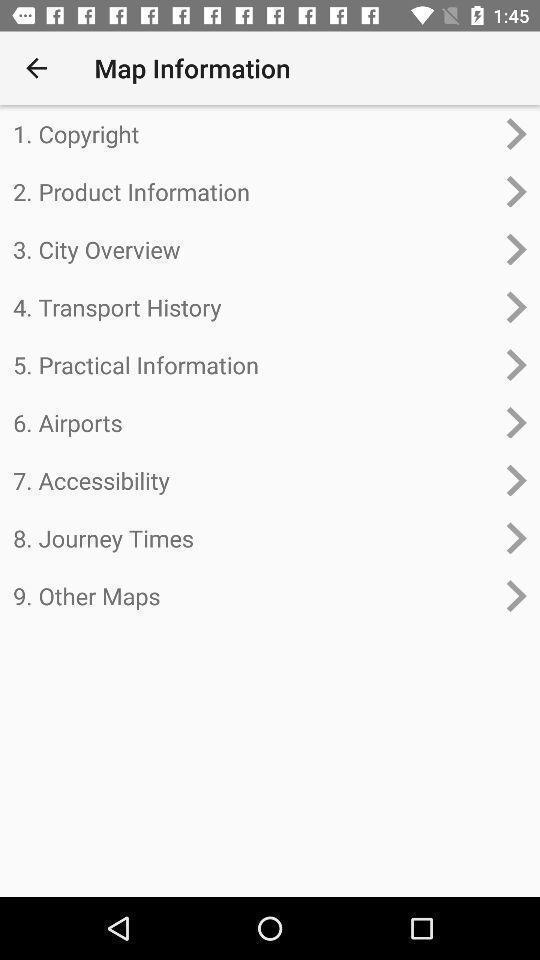Give me a summary of this screen capture. Page showing route planner. 